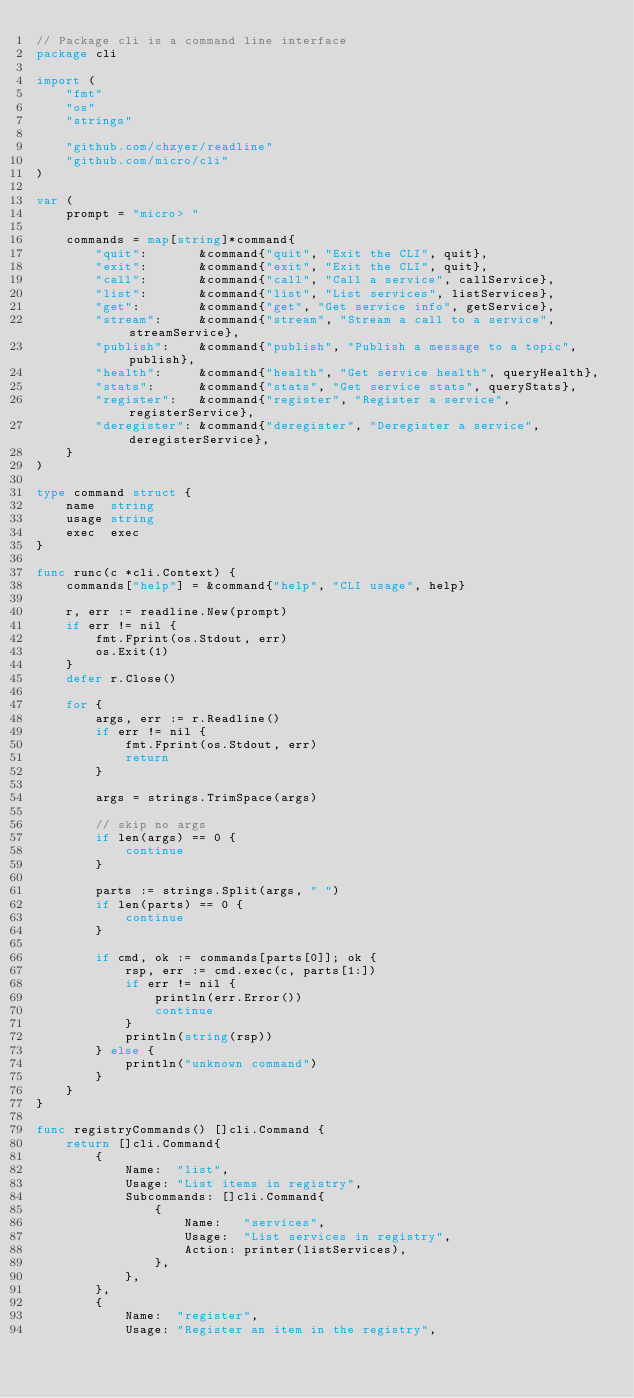Convert code to text. <code><loc_0><loc_0><loc_500><loc_500><_Go_>// Package cli is a command line interface
package cli

import (
	"fmt"
	"os"
	"strings"

	"github.com/chzyer/readline"
	"github.com/micro/cli"
)

var (
	prompt = "micro> "

	commands = map[string]*command{
		"quit":       &command{"quit", "Exit the CLI", quit},
		"exit":       &command{"exit", "Exit the CLI", quit},
		"call":       &command{"call", "Call a service", callService},
		"list":       &command{"list", "List services", listServices},
		"get":        &command{"get", "Get service info", getService},
		"stream":     &command{"stream", "Stream a call to a service", streamService},
		"publish":    &command{"publish", "Publish a message to a topic", publish},
		"health":     &command{"health", "Get service health", queryHealth},
		"stats":      &command{"stats", "Get service stats", queryStats},
		"register":   &command{"register", "Register a service", registerService},
		"deregister": &command{"deregister", "Deregister a service", deregisterService},
	}
)

type command struct {
	name  string
	usage string
	exec  exec
}

func runc(c *cli.Context) {
	commands["help"] = &command{"help", "CLI usage", help}

	r, err := readline.New(prompt)
	if err != nil {
		fmt.Fprint(os.Stdout, err)
		os.Exit(1)
	}
	defer r.Close()

	for {
		args, err := r.Readline()
		if err != nil {
			fmt.Fprint(os.Stdout, err)
			return
		}

		args = strings.TrimSpace(args)

		// skip no args
		if len(args) == 0 {
			continue
		}

		parts := strings.Split(args, " ")
		if len(parts) == 0 {
			continue
		}

		if cmd, ok := commands[parts[0]]; ok {
			rsp, err := cmd.exec(c, parts[1:])
			if err != nil {
				println(err.Error())
				continue
			}
			println(string(rsp))
		} else {
			println("unknown command")
		}
	}
}

func registryCommands() []cli.Command {
	return []cli.Command{
		{
			Name:  "list",
			Usage: "List items in registry",
			Subcommands: []cli.Command{
				{
					Name:   "services",
					Usage:  "List services in registry",
					Action: printer(listServices),
				},
			},
		},
		{
			Name:  "register",
			Usage: "Register an item in the registry",</code> 